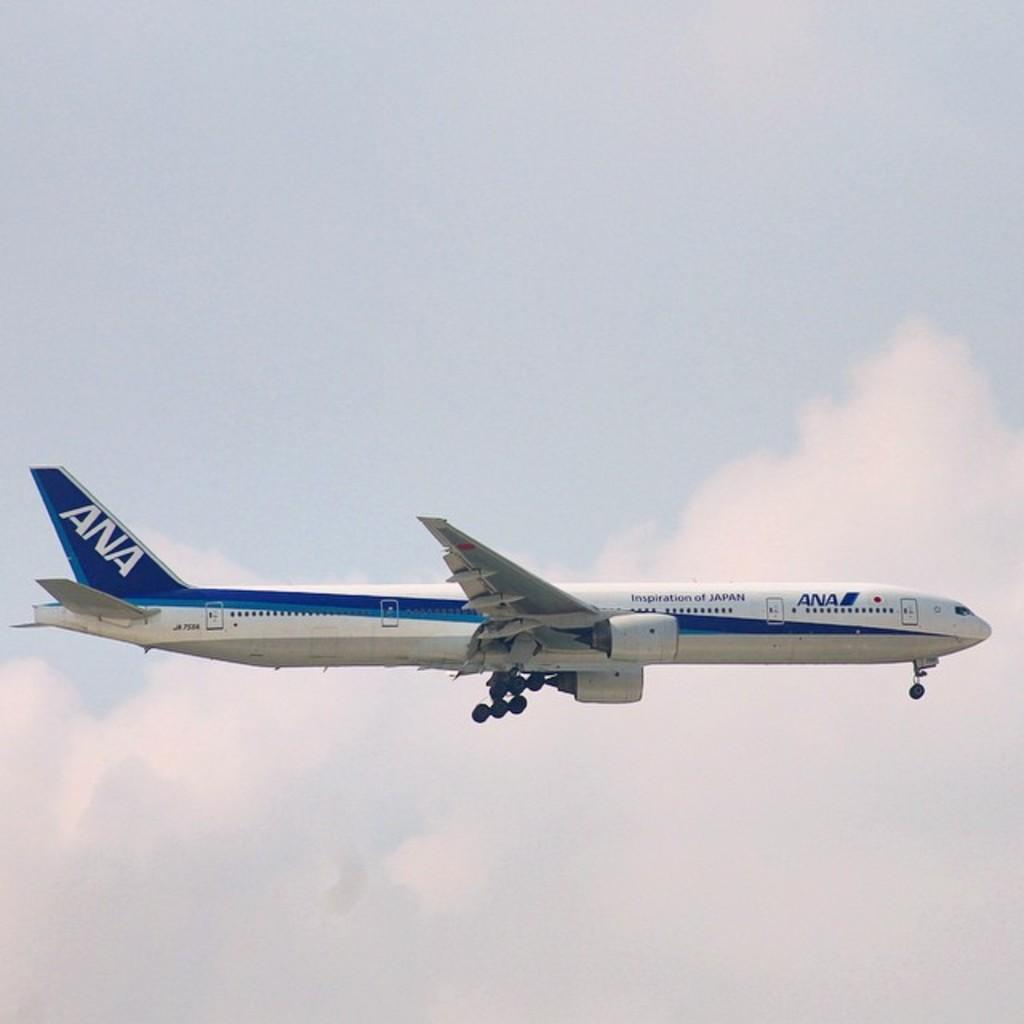<image>
Render a clear and concise summary of the photo. Ana plane is blue and white in flying in the sky 